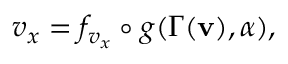<formula> <loc_0><loc_0><loc_500><loc_500>v _ { x } = f _ { v _ { x } } \circ g ( \Gamma ( v ) , \alpha ) ,</formula> 